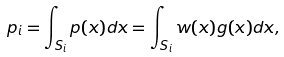Convert formula to latex. <formula><loc_0><loc_0><loc_500><loc_500>p _ { i } = \int _ { S _ { i } } p ( x ) d x = \int _ { S _ { i } } w ( x ) g ( x ) d x ,</formula> 